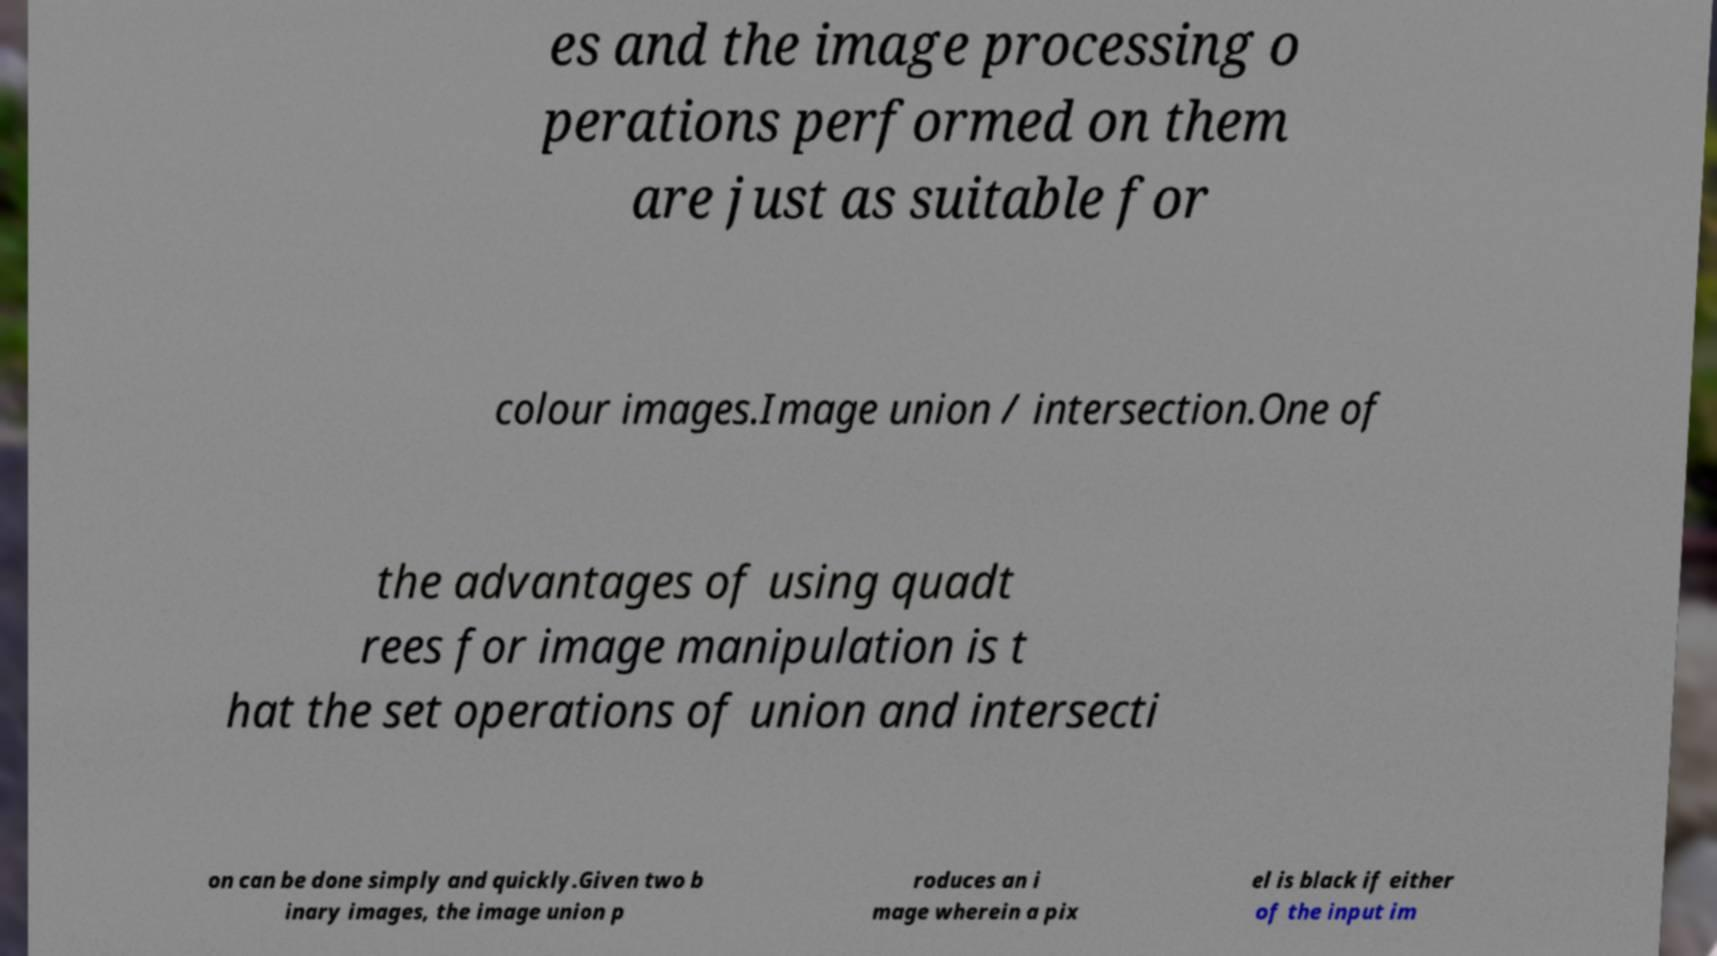For documentation purposes, I need the text within this image transcribed. Could you provide that? es and the image processing o perations performed on them are just as suitable for colour images.Image union / intersection.One of the advantages of using quadt rees for image manipulation is t hat the set operations of union and intersecti on can be done simply and quickly.Given two b inary images, the image union p roduces an i mage wherein a pix el is black if either of the input im 